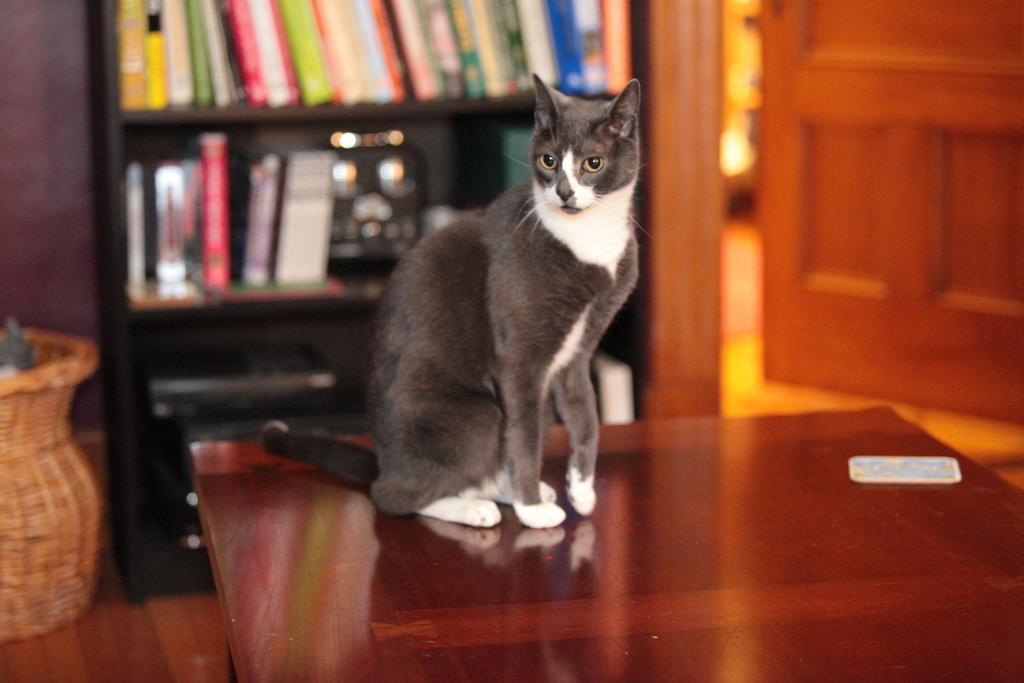How would you summarize this image in a sentence or two? There is a cat behind this table behind this cat there is a bookshelf right side of an image it's a door. n 